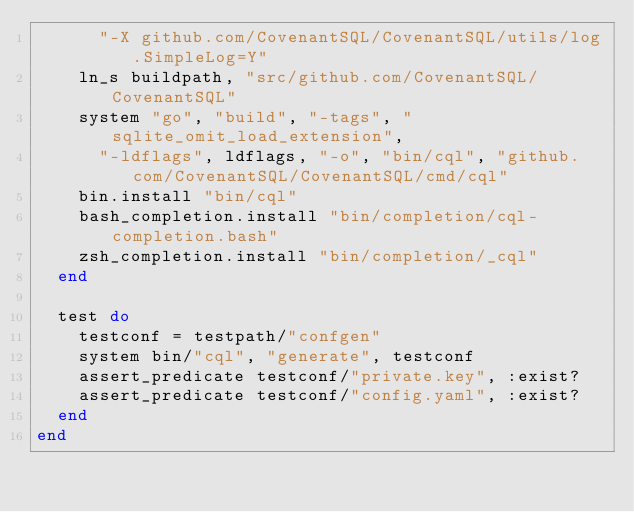Convert code to text. <code><loc_0><loc_0><loc_500><loc_500><_Ruby_>      "-X github.com/CovenantSQL/CovenantSQL/utils/log.SimpleLog=Y"
    ln_s buildpath, "src/github.com/CovenantSQL/CovenantSQL"
    system "go", "build", "-tags", "sqlite_omit_load_extension",
      "-ldflags", ldflags, "-o", "bin/cql", "github.com/CovenantSQL/CovenantSQL/cmd/cql"
    bin.install "bin/cql"
    bash_completion.install "bin/completion/cql-completion.bash"
    zsh_completion.install "bin/completion/_cql"
  end

  test do
    testconf = testpath/"confgen"
    system bin/"cql", "generate", testconf
    assert_predicate testconf/"private.key", :exist?
    assert_predicate testconf/"config.yaml", :exist?
  end
end
</code> 